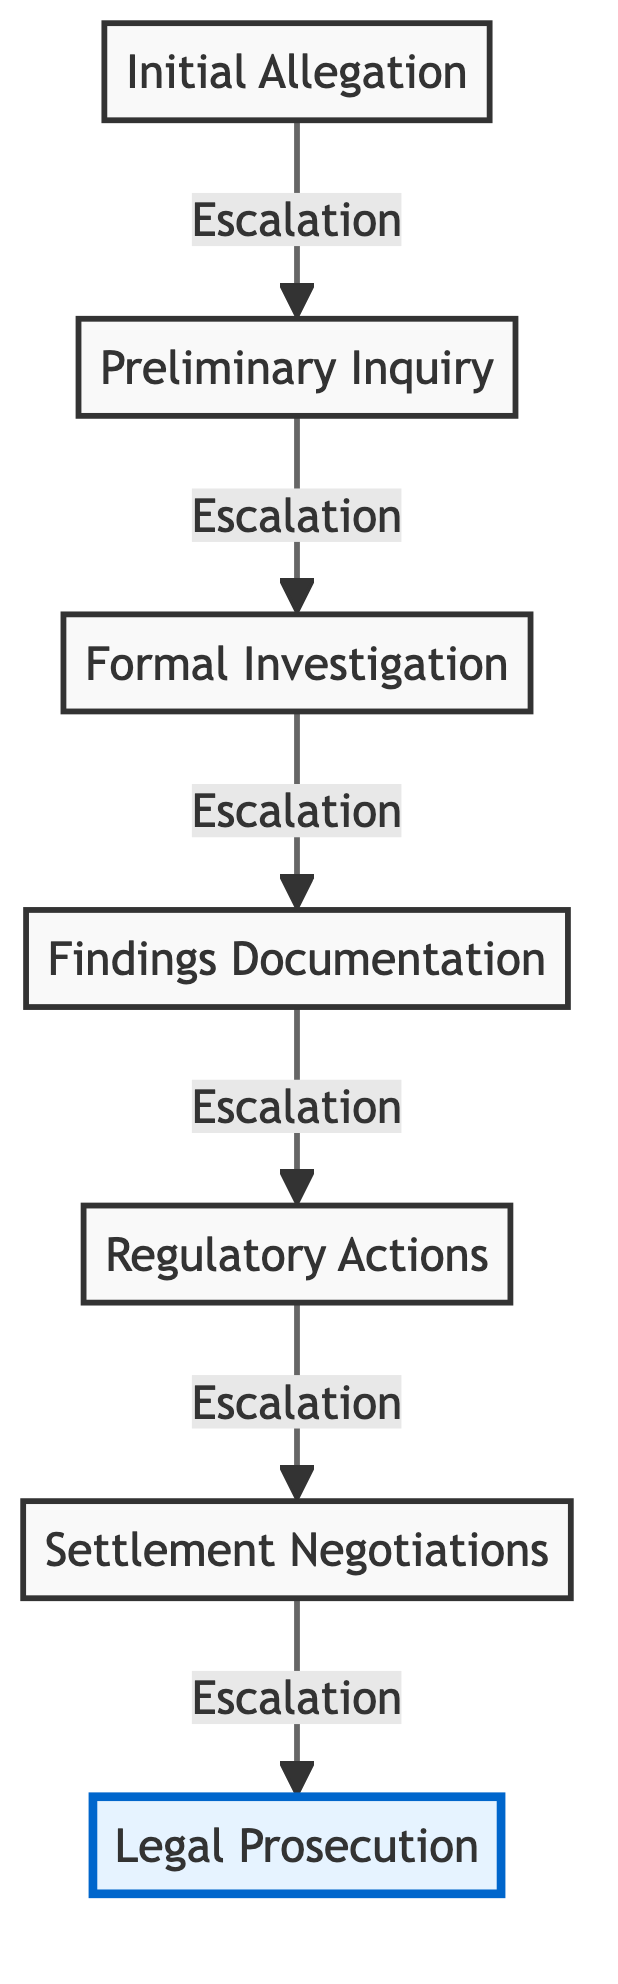What is the final stage in the regulatory investigation flow? The diagram indicates that the final stage is 'Legal Prosecution'. This is the last node at the top of the flow chart, representing the culmination of the investigative process.
Answer: Legal Prosecution How many stages are there in the escalation process? By counting the nodes listed in the flow chart, there are a total of seven stages: Initial Allegation, Preliminary Inquiry, Formal Investigation, Findings Documentation, Regulatory Actions, Settlement Negotiations, and Legal Prosecution.
Answer: 7 What nodes are involved before 'Regulatory Actions'? The nodes that occur before 'Regulatory Actions' in the flow chart are 'Findings Documentation' and 'Formal Investigation'. These two stages lead directly into regulatory actions based on the findings from the investigation.
Answer: Findings Documentation, Formal Investigation Which stage involves negotiations with the corporate entity? The diagram specifies that 'Settlement Negotiations' is the stage where discussions with the corporate entity occur to negotiate outcomes such as settlements or compliance agreements.
Answer: Settlement Negotiations What is the relationship between 'Formal Investigation' and 'Findings Documentation'? 'Formal Investigation' leads to 'Findings Documentation', meaning that after a formal investigation concludes, the next step is to compile findings into documentation. This demonstrates a direct flow leading from the investigation phase to the documentation phase.
Answer: Leads to Which stage would likely require expert reports? From the flow, 'Findings Documentation' is where expert reports are compiled as evidence and support for the investigation, making it clear that this stage includes such documentation.
Answer: Findings Documentation What action follows 'Regulatory Actions' in the diagram? After 'Regulatory Actions', the next and final action in the flow is 'Settlement Negotiations', indicating that regulatory actions may lead to discussions for potential settlements.
Answer: Settlement Negotiations In what direction does the flow chart indicate the escalation occurs? The flow chart shows that escalation occurs upward from the bottom node 'Initial Allegation' to the top node 'Legal Prosecution', illustrating a clear progression through the investigation stages.
Answer: Upward 